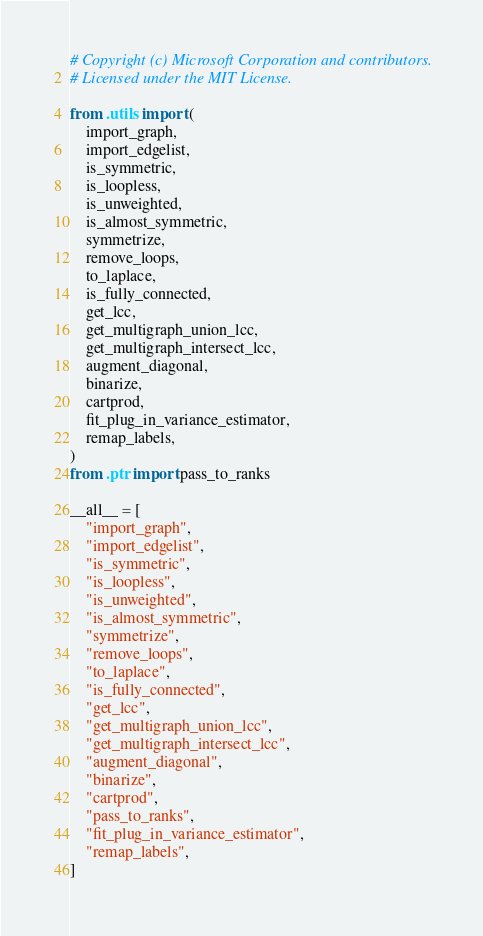<code> <loc_0><loc_0><loc_500><loc_500><_Python_># Copyright (c) Microsoft Corporation and contributors.
# Licensed under the MIT License.

from .utils import (
    import_graph,
    import_edgelist,
    is_symmetric,
    is_loopless,
    is_unweighted,
    is_almost_symmetric,
    symmetrize,
    remove_loops,
    to_laplace,
    is_fully_connected,
    get_lcc,
    get_multigraph_union_lcc,
    get_multigraph_intersect_lcc,
    augment_diagonal,
    binarize,
    cartprod,
    fit_plug_in_variance_estimator,
    remap_labels,
)
from .ptr import pass_to_ranks

__all__ = [
    "import_graph",
    "import_edgelist",
    "is_symmetric",
    "is_loopless",
    "is_unweighted",
    "is_almost_symmetric",
    "symmetrize",
    "remove_loops",
    "to_laplace",
    "is_fully_connected",
    "get_lcc",
    "get_multigraph_union_lcc",
    "get_multigraph_intersect_lcc",
    "augment_diagonal",
    "binarize",
    "cartprod",
    "pass_to_ranks",
    "fit_plug_in_variance_estimator",
    "remap_labels",
]
</code> 